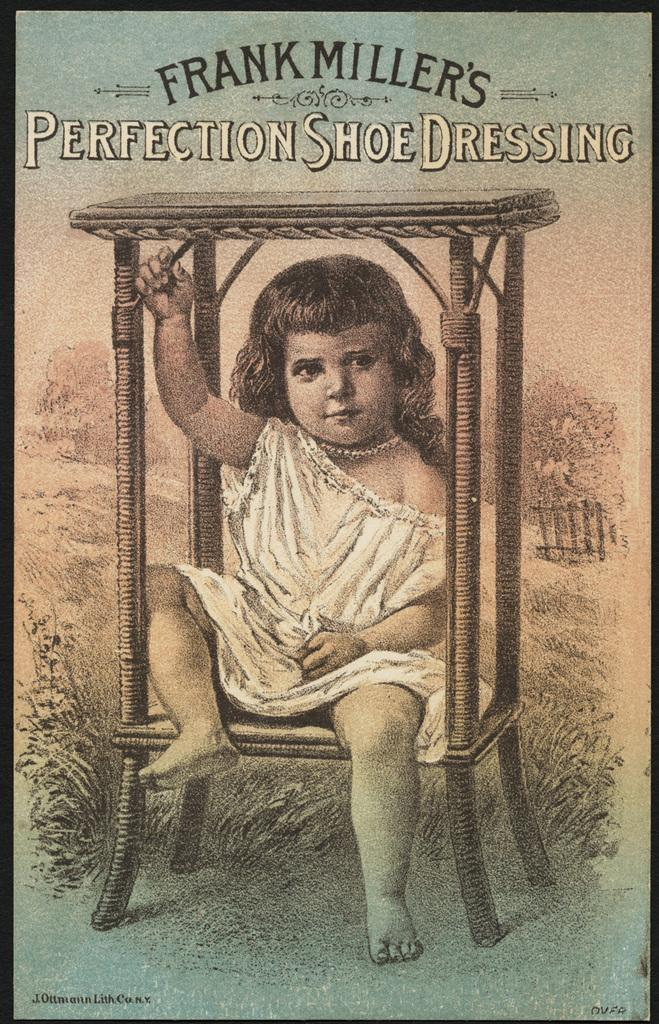Provide a one-sentence caption for the provided image. Cover of Frank millers Perfection Shoe Dressing with an illustration of a child. 